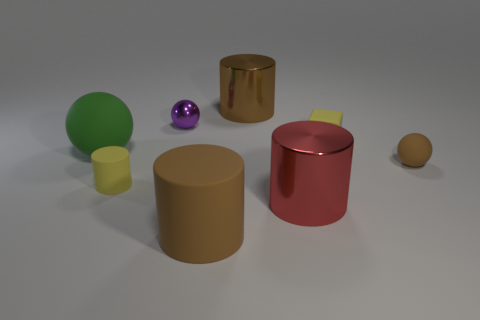There is a brown cylinder that is in front of the big green rubber ball; is its size the same as the brown cylinder behind the small purple ball?
Offer a very short reply. Yes. How many objects are small spheres behind the green rubber thing or large things in front of the yellow rubber cube?
Offer a very short reply. 4. There is a matte object in front of the red shiny cylinder; does it have the same color as the big shiny object behind the green matte object?
Your response must be concise. Yes. How many shiny things are tiny cylinders or yellow objects?
Provide a short and direct response. 0. The big rubber thing in front of the big metal cylinder that is on the right side of the large brown shiny thing is what shape?
Make the answer very short. Cylinder. Does the tiny ball that is in front of the large ball have the same material as the yellow thing that is in front of the green ball?
Provide a short and direct response. Yes. There is a matte ball behind the brown ball; what number of big shiny objects are in front of it?
Offer a very short reply. 1. There is a small object behind the small matte block; does it have the same shape as the rubber thing behind the big green object?
Offer a terse response. No. There is a cylinder that is both in front of the small purple thing and on the right side of the big rubber cylinder; how big is it?
Ensure brevity in your answer.  Large. The tiny matte thing that is the same shape as the large red metal object is what color?
Offer a very short reply. Yellow. 